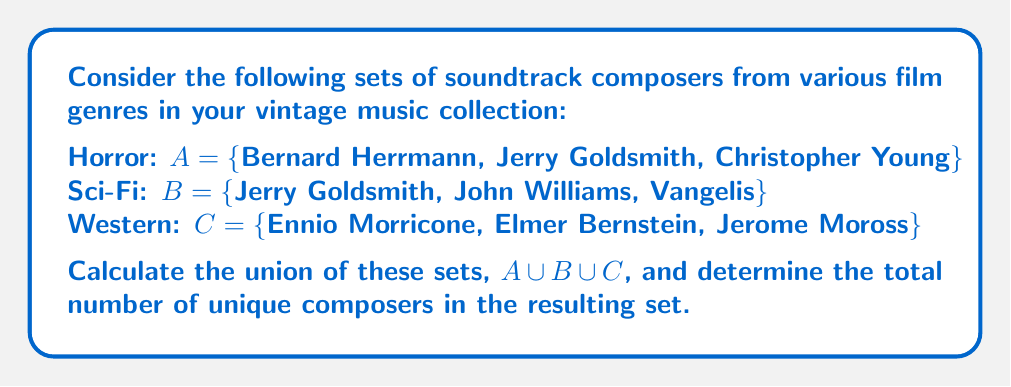Could you help me with this problem? To solve this problem, we need to follow these steps:

1. Understand the concept of union:
   The union of sets $A$, $B$, and $C$ includes all elements that are in $A$, or in $B$, or in $C$ (or in any combination of these sets).

2. List all unique elements:
   We'll list all composers from each set, avoiding duplicates:

   From set $A$: Bernard Herrmann, Jerry Goldsmith, Christopher Young
   From set $B$: Jerry Goldsmith (already listed), John Williams, Vangelis
   From set $C$: Ennio Morricone, Elmer Bernstein, Jerome Moross

3. Combine the unique elements:
   $A \cup B \cup C = \{$Bernard Herrmann, Jerry Goldsmith, Christopher Young, John Williams, Vangelis, Ennio Morricone, Elmer Bernstein, Jerome Moross$\}$

4. Count the number of elements in the resulting set:
   There are 8 unique composers in the union of these sets.

The union operation can be represented mathematically as:

$$A \cup B \cup C = \{x \mid x \in A \lor x \in B \lor x \in C\}$$

Where $\lor$ represents the logical "or" operation.
Answer: The union of sets $A$, $B$, and $C$ is:

$A \cup B \cup C = \{$Bernard Herrmann, Jerry Goldsmith, Christopher Young, John Williams, Vangelis, Ennio Morricone, Elmer Bernstein, Jerome Moross$\}$

The total number of unique composers in the resulting set is 8. 